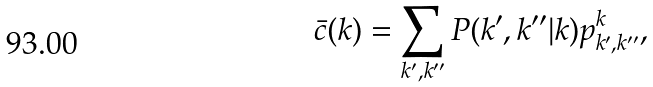<formula> <loc_0><loc_0><loc_500><loc_500>\bar { c } ( k ) = \sum _ { k ^ { \prime } , k ^ { \prime \prime } } P ( k ^ { \prime } , k ^ { \prime \prime } | k ) p ^ { k } _ { k ^ { \prime } , k ^ { \prime \prime } } ,</formula> 